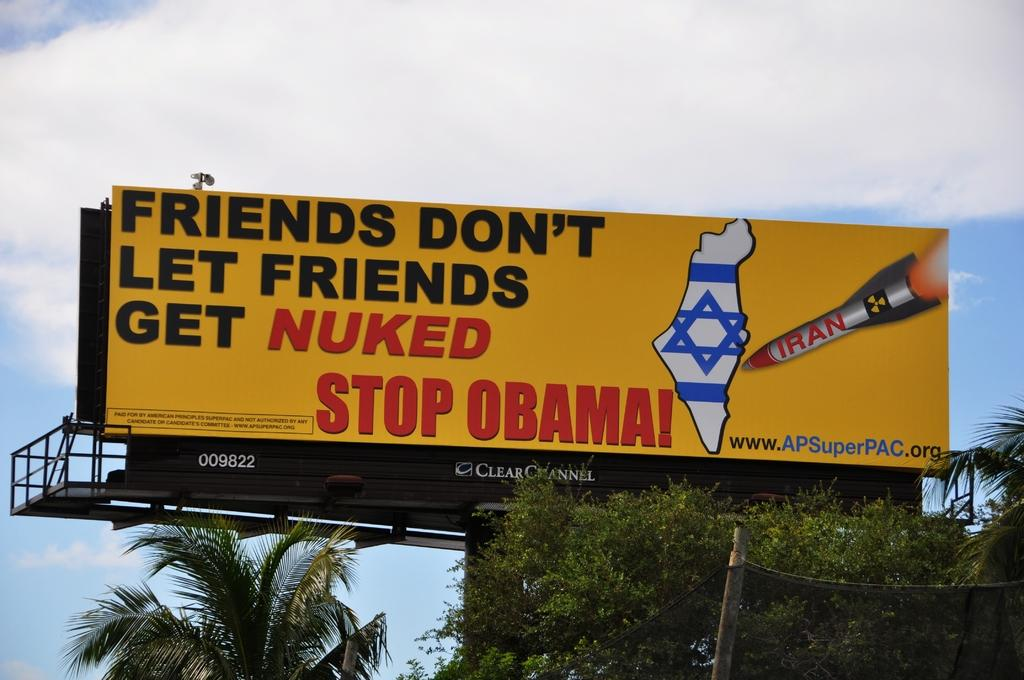<image>
Share a concise interpretation of the image provided. A bright yellow billboard asks that Obama be stopped. 